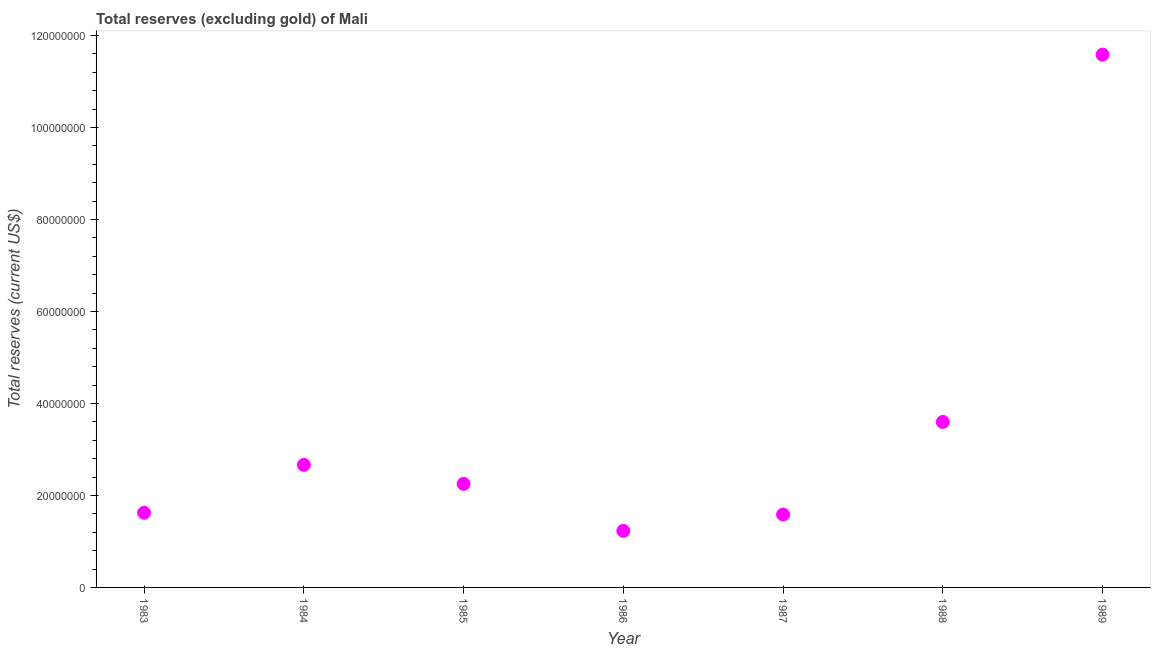What is the total reserves (excluding gold) in 1984?
Offer a terse response. 2.66e+07. Across all years, what is the maximum total reserves (excluding gold)?
Ensure brevity in your answer.  1.16e+08. Across all years, what is the minimum total reserves (excluding gold)?
Your answer should be very brief. 1.23e+07. In which year was the total reserves (excluding gold) minimum?
Make the answer very short. 1986. What is the sum of the total reserves (excluding gold)?
Provide a short and direct response. 2.45e+08. What is the difference between the total reserves (excluding gold) in 1983 and 1985?
Give a very brief answer. -6.28e+06. What is the average total reserves (excluding gold) per year?
Your answer should be compact. 3.50e+07. What is the median total reserves (excluding gold)?
Keep it short and to the point. 2.25e+07. Do a majority of the years between 1984 and 1987 (inclusive) have total reserves (excluding gold) greater than 116000000 US$?
Your answer should be very brief. No. What is the ratio of the total reserves (excluding gold) in 1984 to that in 1985?
Offer a very short reply. 1.18. Is the difference between the total reserves (excluding gold) in 1987 and 1989 greater than the difference between any two years?
Keep it short and to the point. No. What is the difference between the highest and the second highest total reserves (excluding gold)?
Provide a short and direct response. 7.98e+07. Is the sum of the total reserves (excluding gold) in 1985 and 1988 greater than the maximum total reserves (excluding gold) across all years?
Your answer should be very brief. No. What is the difference between the highest and the lowest total reserves (excluding gold)?
Offer a very short reply. 1.04e+08. Does the total reserves (excluding gold) monotonically increase over the years?
Provide a succinct answer. No. How many dotlines are there?
Provide a short and direct response. 1. Are the values on the major ticks of Y-axis written in scientific E-notation?
Your response must be concise. No. Does the graph contain any zero values?
Make the answer very short. No. What is the title of the graph?
Offer a terse response. Total reserves (excluding gold) of Mali. What is the label or title of the X-axis?
Give a very brief answer. Year. What is the label or title of the Y-axis?
Ensure brevity in your answer.  Total reserves (current US$). What is the Total reserves (current US$) in 1983?
Your answer should be very brief. 1.62e+07. What is the Total reserves (current US$) in 1984?
Offer a very short reply. 2.66e+07. What is the Total reserves (current US$) in 1985?
Offer a terse response. 2.25e+07. What is the Total reserves (current US$) in 1986?
Your response must be concise. 1.23e+07. What is the Total reserves (current US$) in 1987?
Offer a terse response. 1.58e+07. What is the Total reserves (current US$) in 1988?
Provide a short and direct response. 3.60e+07. What is the Total reserves (current US$) in 1989?
Offer a terse response. 1.16e+08. What is the difference between the Total reserves (current US$) in 1983 and 1984?
Provide a succinct answer. -1.04e+07. What is the difference between the Total reserves (current US$) in 1983 and 1985?
Your response must be concise. -6.28e+06. What is the difference between the Total reserves (current US$) in 1983 and 1986?
Give a very brief answer. 3.95e+06. What is the difference between the Total reserves (current US$) in 1983 and 1987?
Provide a short and direct response. 3.85e+05. What is the difference between the Total reserves (current US$) in 1983 and 1988?
Make the answer very short. -1.97e+07. What is the difference between the Total reserves (current US$) in 1983 and 1989?
Your answer should be compact. -9.96e+07. What is the difference between the Total reserves (current US$) in 1984 and 1985?
Your response must be concise. 4.12e+06. What is the difference between the Total reserves (current US$) in 1984 and 1986?
Make the answer very short. 1.44e+07. What is the difference between the Total reserves (current US$) in 1984 and 1987?
Make the answer very short. 1.08e+07. What is the difference between the Total reserves (current US$) in 1984 and 1988?
Offer a terse response. -9.33e+06. What is the difference between the Total reserves (current US$) in 1984 and 1989?
Keep it short and to the point. -8.92e+07. What is the difference between the Total reserves (current US$) in 1985 and 1986?
Your response must be concise. 1.02e+07. What is the difference between the Total reserves (current US$) in 1985 and 1987?
Give a very brief answer. 6.67e+06. What is the difference between the Total reserves (current US$) in 1985 and 1988?
Offer a very short reply. -1.35e+07. What is the difference between the Total reserves (current US$) in 1985 and 1989?
Keep it short and to the point. -9.33e+07. What is the difference between the Total reserves (current US$) in 1986 and 1987?
Give a very brief answer. -3.56e+06. What is the difference between the Total reserves (current US$) in 1986 and 1988?
Your answer should be very brief. -2.37e+07. What is the difference between the Total reserves (current US$) in 1986 and 1989?
Provide a succinct answer. -1.04e+08. What is the difference between the Total reserves (current US$) in 1987 and 1988?
Ensure brevity in your answer.  -2.01e+07. What is the difference between the Total reserves (current US$) in 1987 and 1989?
Your answer should be very brief. -1.00e+08. What is the difference between the Total reserves (current US$) in 1988 and 1989?
Your answer should be compact. -7.98e+07. What is the ratio of the Total reserves (current US$) in 1983 to that in 1984?
Your answer should be compact. 0.61. What is the ratio of the Total reserves (current US$) in 1983 to that in 1985?
Make the answer very short. 0.72. What is the ratio of the Total reserves (current US$) in 1983 to that in 1986?
Your answer should be compact. 1.32. What is the ratio of the Total reserves (current US$) in 1983 to that in 1987?
Ensure brevity in your answer.  1.02. What is the ratio of the Total reserves (current US$) in 1983 to that in 1988?
Keep it short and to the point. 0.45. What is the ratio of the Total reserves (current US$) in 1983 to that in 1989?
Give a very brief answer. 0.14. What is the ratio of the Total reserves (current US$) in 1984 to that in 1985?
Make the answer very short. 1.18. What is the ratio of the Total reserves (current US$) in 1984 to that in 1986?
Offer a terse response. 2.17. What is the ratio of the Total reserves (current US$) in 1984 to that in 1987?
Offer a terse response. 1.68. What is the ratio of the Total reserves (current US$) in 1984 to that in 1988?
Offer a terse response. 0.74. What is the ratio of the Total reserves (current US$) in 1984 to that in 1989?
Ensure brevity in your answer.  0.23. What is the ratio of the Total reserves (current US$) in 1985 to that in 1986?
Provide a short and direct response. 1.83. What is the ratio of the Total reserves (current US$) in 1985 to that in 1987?
Ensure brevity in your answer.  1.42. What is the ratio of the Total reserves (current US$) in 1985 to that in 1988?
Ensure brevity in your answer.  0.63. What is the ratio of the Total reserves (current US$) in 1985 to that in 1989?
Your answer should be compact. 0.19. What is the ratio of the Total reserves (current US$) in 1986 to that in 1987?
Your answer should be very brief. 0.78. What is the ratio of the Total reserves (current US$) in 1986 to that in 1988?
Provide a short and direct response. 0.34. What is the ratio of the Total reserves (current US$) in 1986 to that in 1989?
Your response must be concise. 0.11. What is the ratio of the Total reserves (current US$) in 1987 to that in 1988?
Your answer should be compact. 0.44. What is the ratio of the Total reserves (current US$) in 1987 to that in 1989?
Give a very brief answer. 0.14. What is the ratio of the Total reserves (current US$) in 1988 to that in 1989?
Your response must be concise. 0.31. 